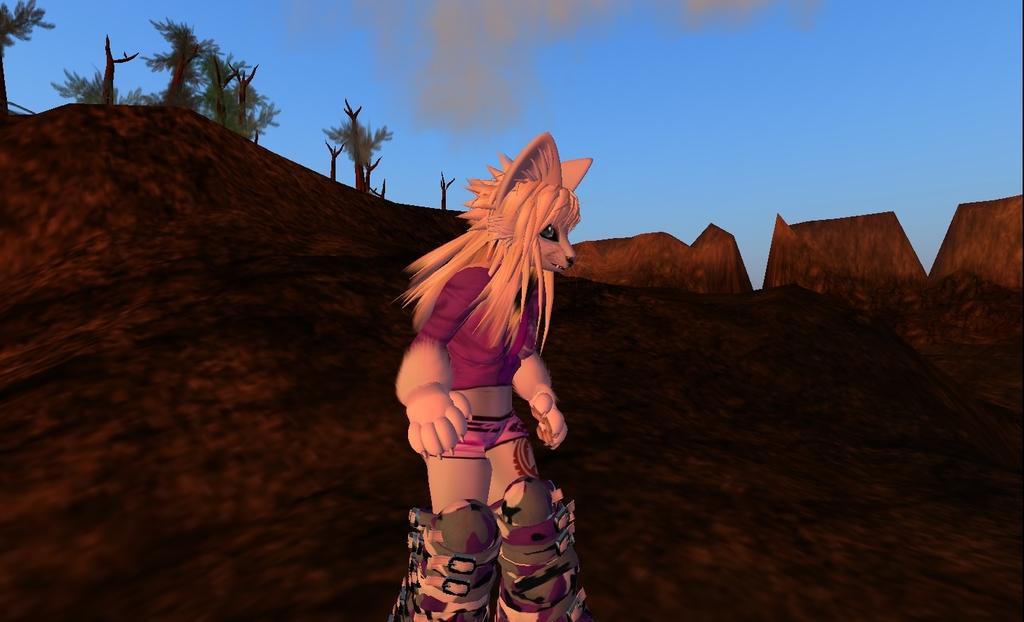In one or two sentences, can you explain what this image depicts? In the foreground of this picture, where we can see centaur in the center. In the background, we can see mountains, trees, sky and the cloud. 